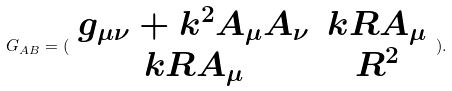Convert formula to latex. <formula><loc_0><loc_0><loc_500><loc_500>G _ { A B } = ( \begin{array} { c c } g _ { \mu \nu } + k ^ { 2 } A _ { \mu } A _ { \nu } & k R A _ { \mu } \\ k R A _ { \mu } & R ^ { 2 } \end{array} ) .</formula> 